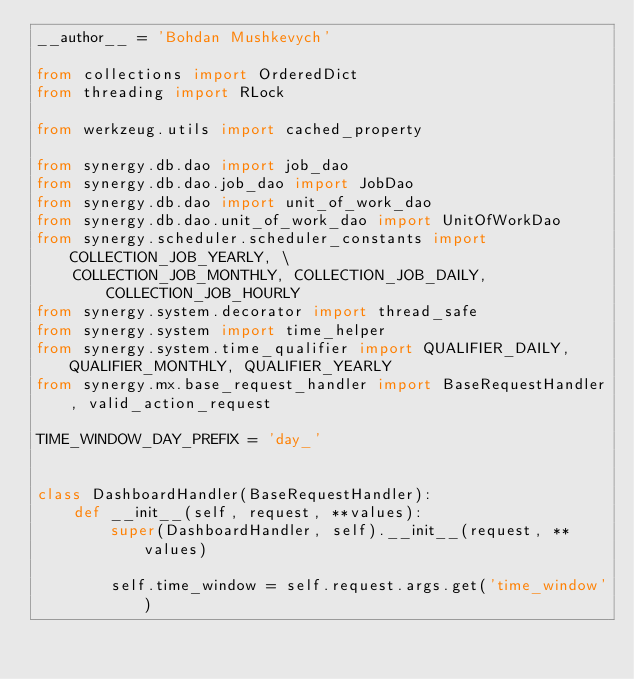<code> <loc_0><loc_0><loc_500><loc_500><_Python_>__author__ = 'Bohdan Mushkevych'

from collections import OrderedDict
from threading import RLock

from werkzeug.utils import cached_property

from synergy.db.dao import job_dao
from synergy.db.dao.job_dao import JobDao
from synergy.db.dao import unit_of_work_dao
from synergy.db.dao.unit_of_work_dao import UnitOfWorkDao
from synergy.scheduler.scheduler_constants import COLLECTION_JOB_YEARLY, \
    COLLECTION_JOB_MONTHLY, COLLECTION_JOB_DAILY, COLLECTION_JOB_HOURLY
from synergy.system.decorator import thread_safe
from synergy.system import time_helper
from synergy.system.time_qualifier import QUALIFIER_DAILY, QUALIFIER_MONTHLY, QUALIFIER_YEARLY
from synergy.mx.base_request_handler import BaseRequestHandler, valid_action_request

TIME_WINDOW_DAY_PREFIX = 'day_'


class DashboardHandler(BaseRequestHandler):
    def __init__(self, request, **values):
        super(DashboardHandler, self).__init__(request, **values)

        self.time_window = self.request.args.get('time_window')</code> 